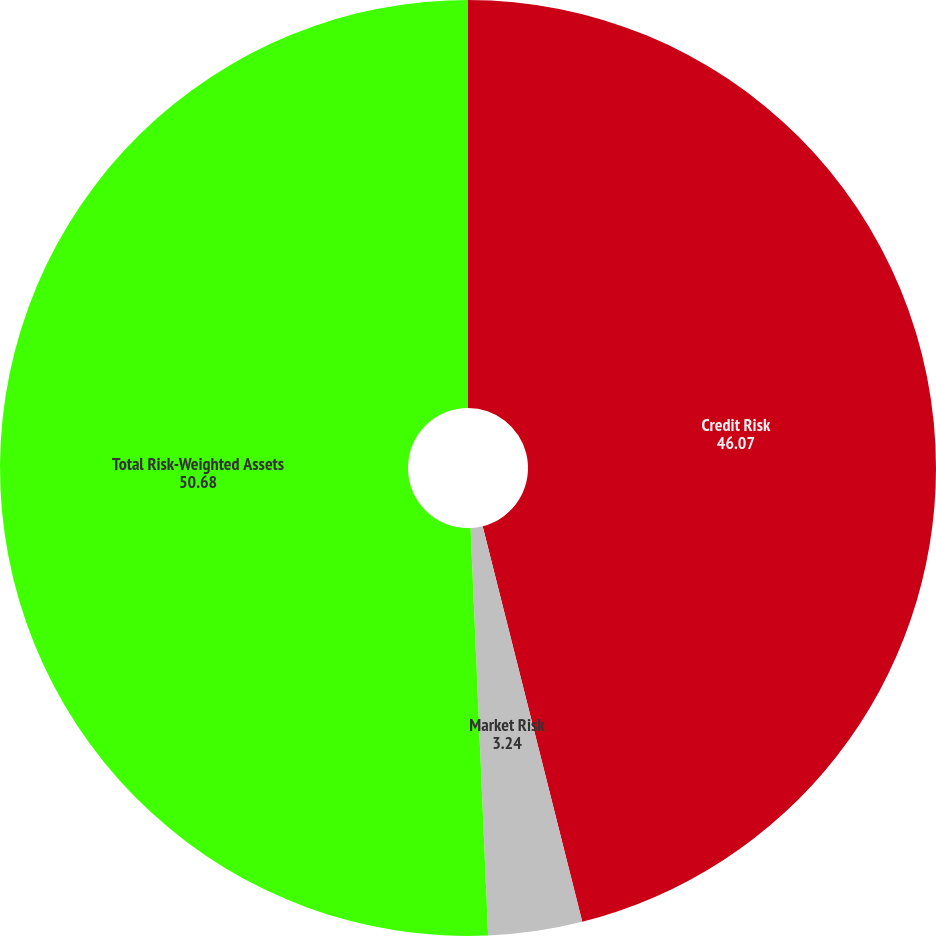<chart> <loc_0><loc_0><loc_500><loc_500><pie_chart><fcel>Credit Risk<fcel>Market Risk<fcel>Total Risk-Weighted Assets<nl><fcel>46.07%<fcel>3.24%<fcel>50.68%<nl></chart> 